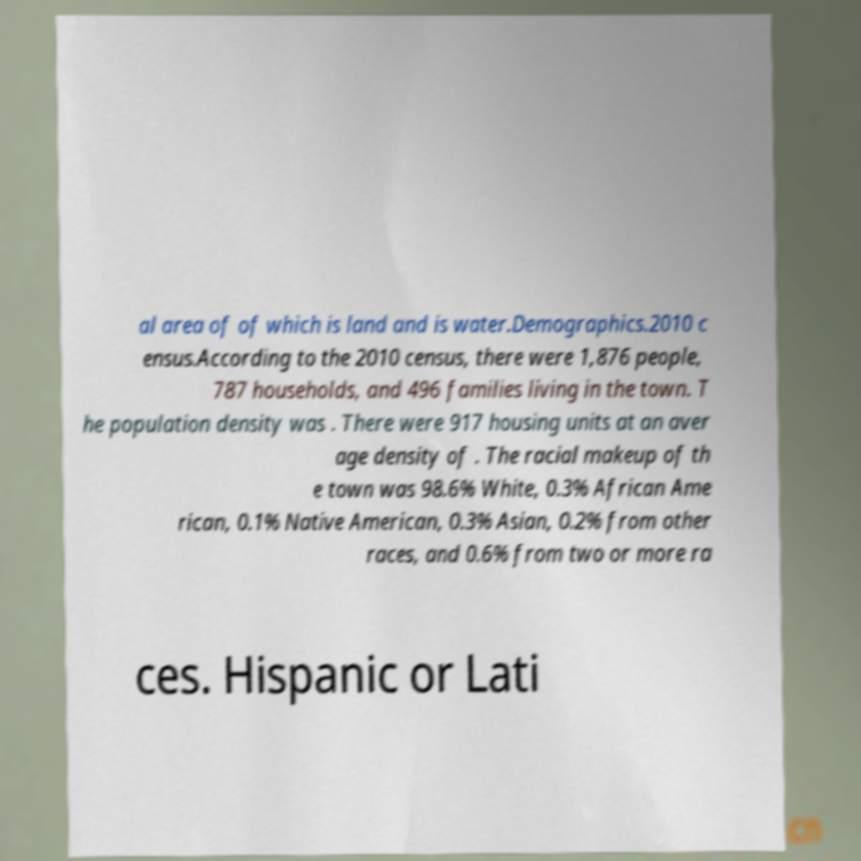Can you read and provide the text displayed in the image?This photo seems to have some interesting text. Can you extract and type it out for me? al area of of which is land and is water.Demographics.2010 c ensus.According to the 2010 census, there were 1,876 people, 787 households, and 496 families living in the town. T he population density was . There were 917 housing units at an aver age density of . The racial makeup of th e town was 98.6% White, 0.3% African Ame rican, 0.1% Native American, 0.3% Asian, 0.2% from other races, and 0.6% from two or more ra ces. Hispanic or Lati 